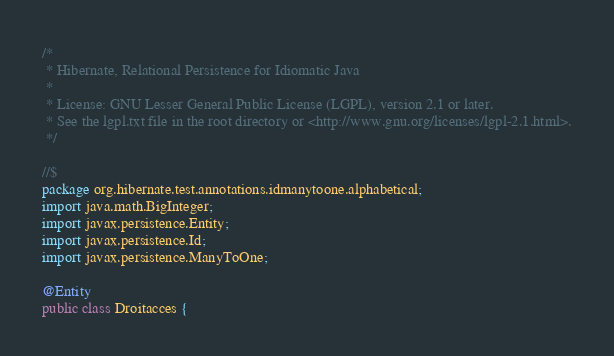Convert code to text. <code><loc_0><loc_0><loc_500><loc_500><_Java_>/*
 * Hibernate, Relational Persistence for Idiomatic Java
 *
 * License: GNU Lesser General Public License (LGPL), version 2.1 or later.
 * See the lgpl.txt file in the root directory or <http://www.gnu.org/licenses/lgpl-2.1.html>.
 */

//$
package org.hibernate.test.annotations.idmanytoone.alphabetical;
import java.math.BigInteger;
import javax.persistence.Entity;
import javax.persistence.Id;
import javax.persistence.ManyToOne;

@Entity
public class Droitacces {</code> 